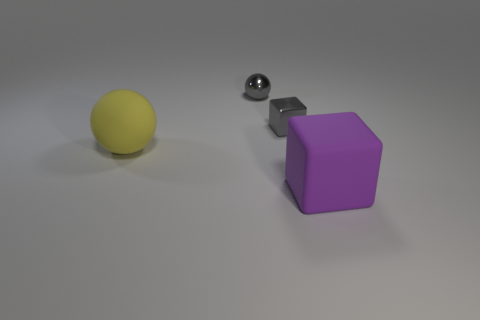How many other things are the same shape as the large yellow matte object?
Your answer should be very brief. 1. What is the shape of the gray shiny thing that is in front of the small metal ball?
Keep it short and to the point. Cube. There is a yellow matte object; is it the same shape as the tiny object that is right of the small metallic ball?
Keep it short and to the point. No. What size is the object that is on the left side of the tiny gray metallic block and to the right of the yellow ball?
Keep it short and to the point. Small. There is a thing that is both in front of the tiny block and on the right side of the yellow ball; what is its color?
Offer a terse response. Purple. Is there anything else that has the same material as the big block?
Provide a short and direct response. Yes. Are there fewer big things left of the big yellow object than gray metallic blocks that are right of the gray block?
Your response must be concise. No. Are there any other things that have the same color as the small shiny sphere?
Provide a succinct answer. Yes. There is a big purple rubber thing; what shape is it?
Provide a succinct answer. Cube. There is another large object that is made of the same material as the large purple thing; what is its color?
Provide a short and direct response. Yellow. 